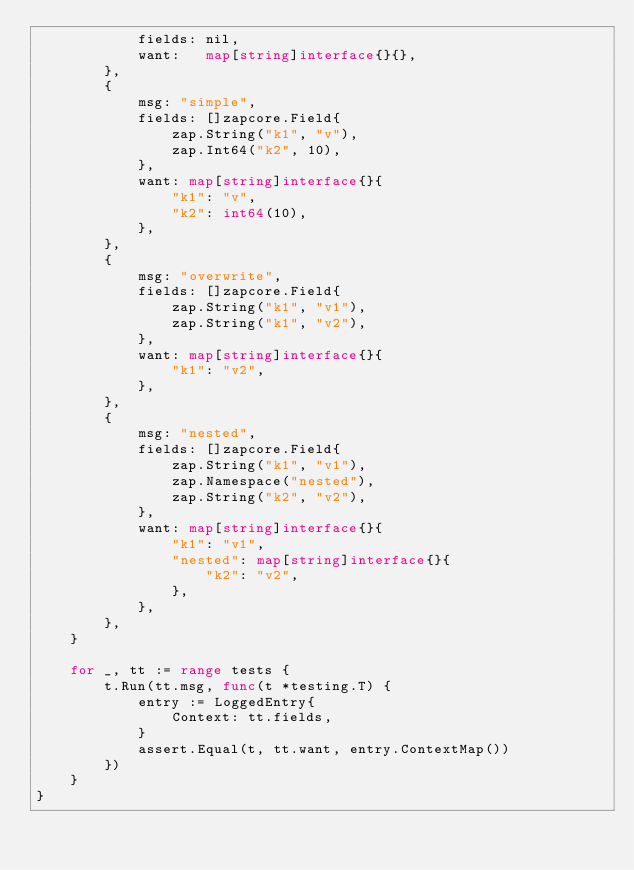Convert code to text. <code><loc_0><loc_0><loc_500><loc_500><_Go_>			fields: nil,
			want:   map[string]interface{}{},
		},
		{
			msg: "simple",
			fields: []zapcore.Field{
				zap.String("k1", "v"),
				zap.Int64("k2", 10),
			},
			want: map[string]interface{}{
				"k1": "v",
				"k2": int64(10),
			},
		},
		{
			msg: "overwrite",
			fields: []zapcore.Field{
				zap.String("k1", "v1"),
				zap.String("k1", "v2"),
			},
			want: map[string]interface{}{
				"k1": "v2",
			},
		},
		{
			msg: "nested",
			fields: []zapcore.Field{
				zap.String("k1", "v1"),
				zap.Namespace("nested"),
				zap.String("k2", "v2"),
			},
			want: map[string]interface{}{
				"k1": "v1",
				"nested": map[string]interface{}{
					"k2": "v2",
				},
			},
		},
	}

	for _, tt := range tests {
		t.Run(tt.msg, func(t *testing.T) {
			entry := LoggedEntry{
				Context: tt.fields,
			}
			assert.Equal(t, tt.want, entry.ContextMap())
		})
	}
}
</code> 